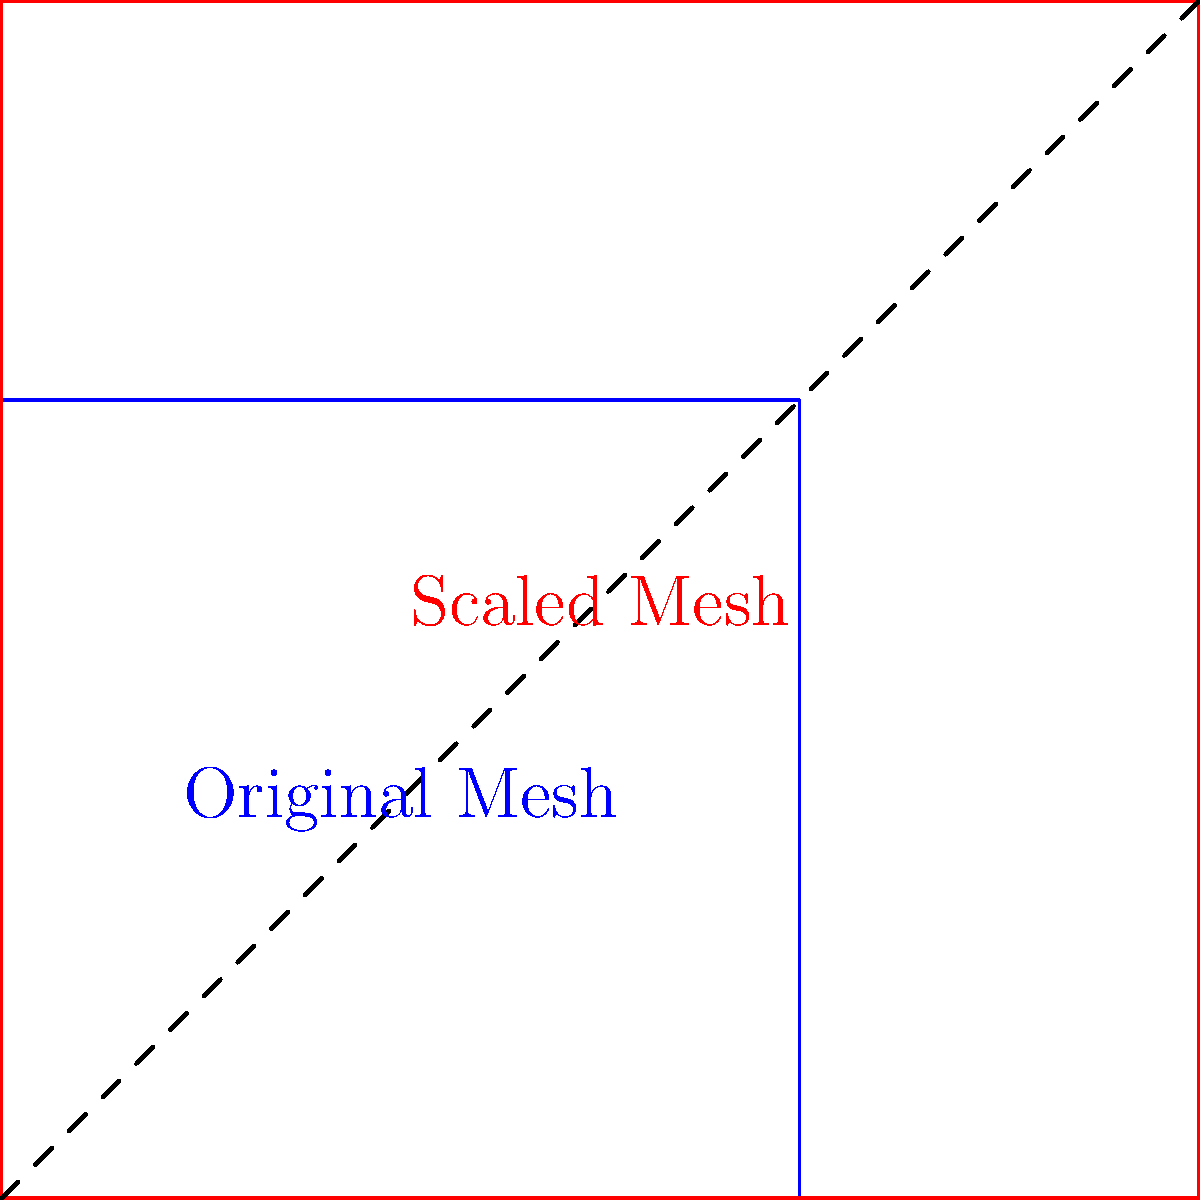A protective fabric mesh is designed with a density of 100 threads per square inch. To increase its protective capabilities, you need to scale the mesh to achieve a new density of 225 threads per square inch. By what factor should you scale the original mesh to achieve this new density? To solve this problem, we need to understand the relationship between scaling and density:

1. The original density is 100 threads per square inch.
2. The desired new density is 225 threads per square inch.
3. Density is proportional to the square of the scaling factor, because we're dealing with a two-dimensional mesh.

Let's define the scaling factor as $x$. Then:

4. The new density = Original density * $x^2$
5. $225 = 100 * x^2$
6. Dividing both sides by 100: $2.25 = x^2$
7. Taking the square root of both sides: $x = \sqrt{2.25}$
8. Simplifying: $x = 1.5$

Therefore, to increase the density from 100 to 225 threads per square inch, we need to scale the original mesh by a factor of 1.5 in both directions.
Answer: 1.5 